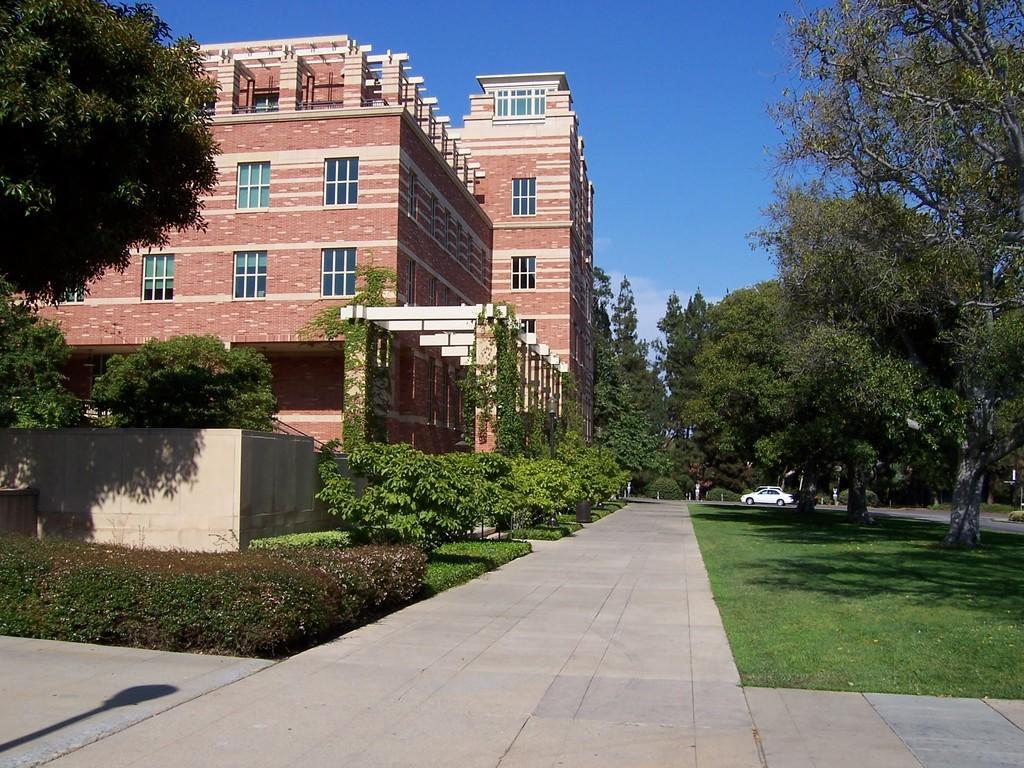Describe this image in one or two sentences. As we can see in the image there are buildings, trees, plants, grass and sky. In the background there is a white color car. 